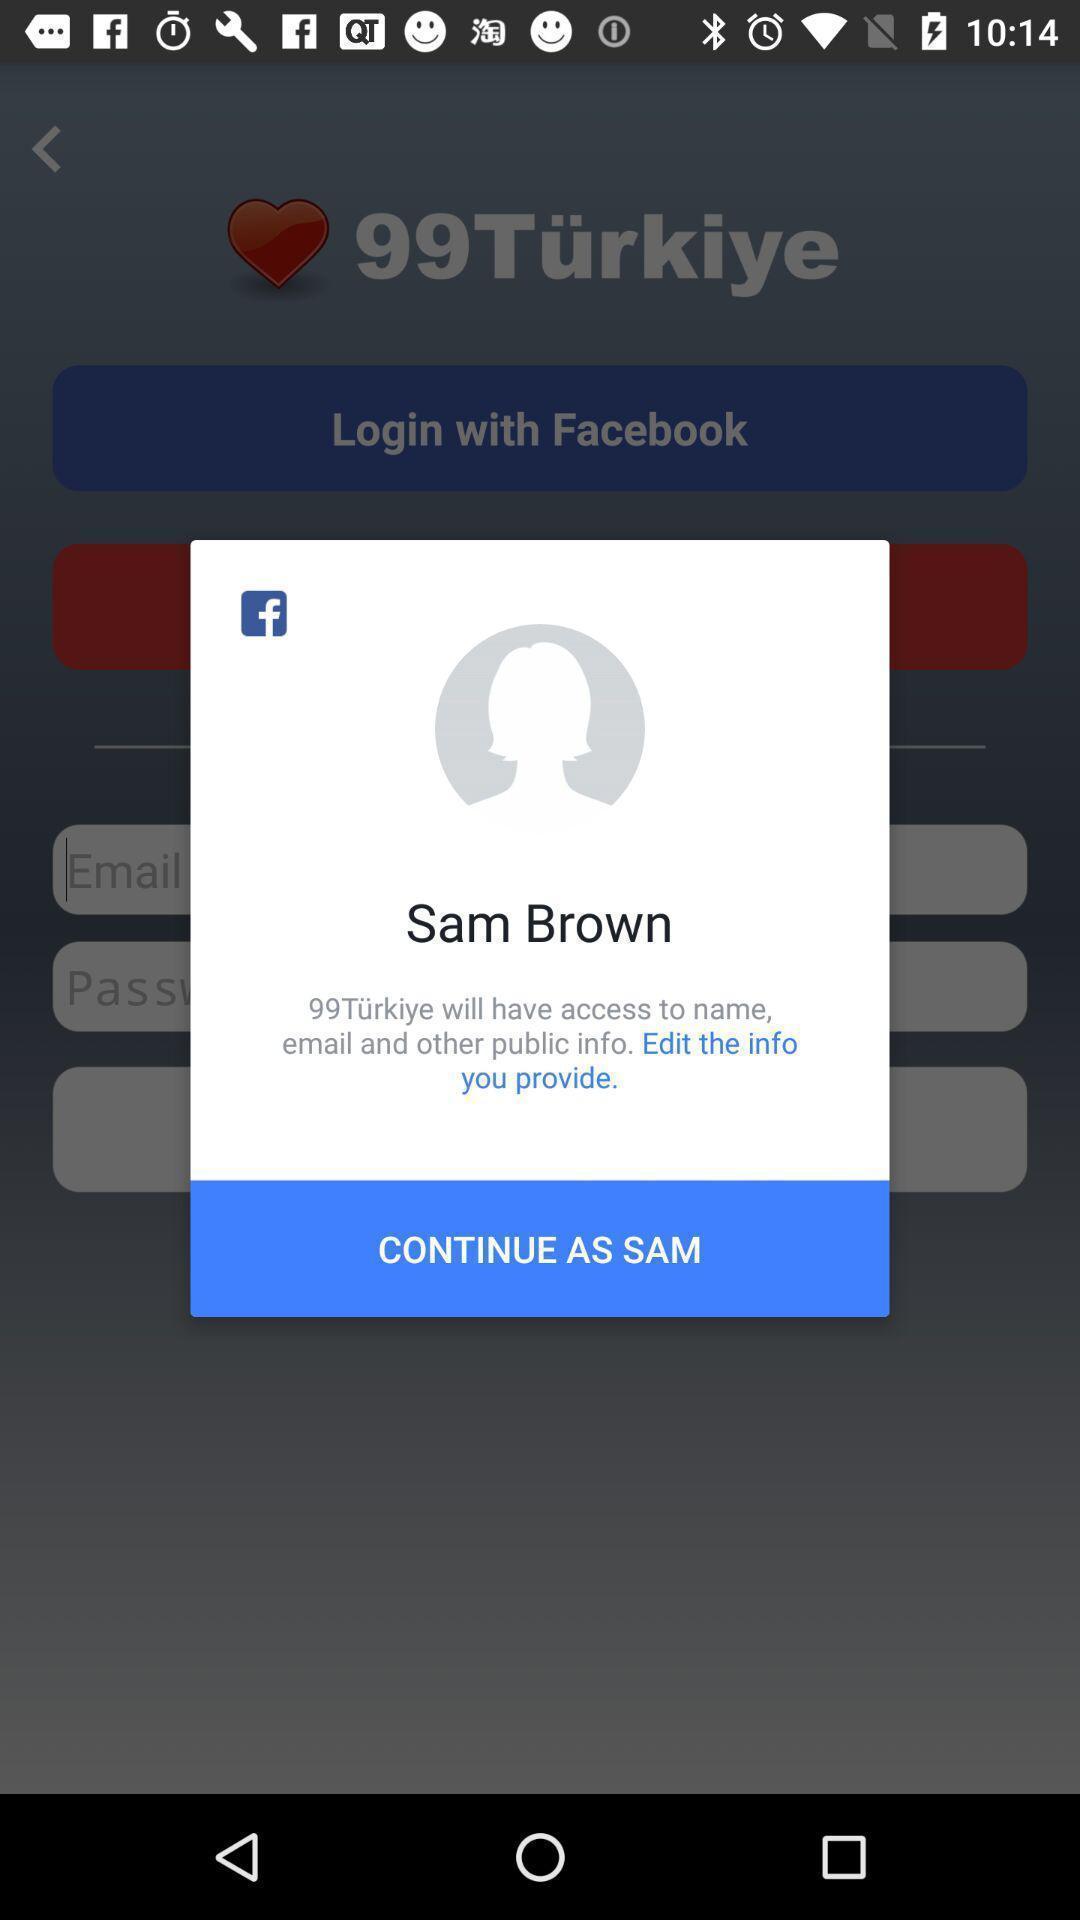What can you discern from this picture? Pop up of login with social app profile. 